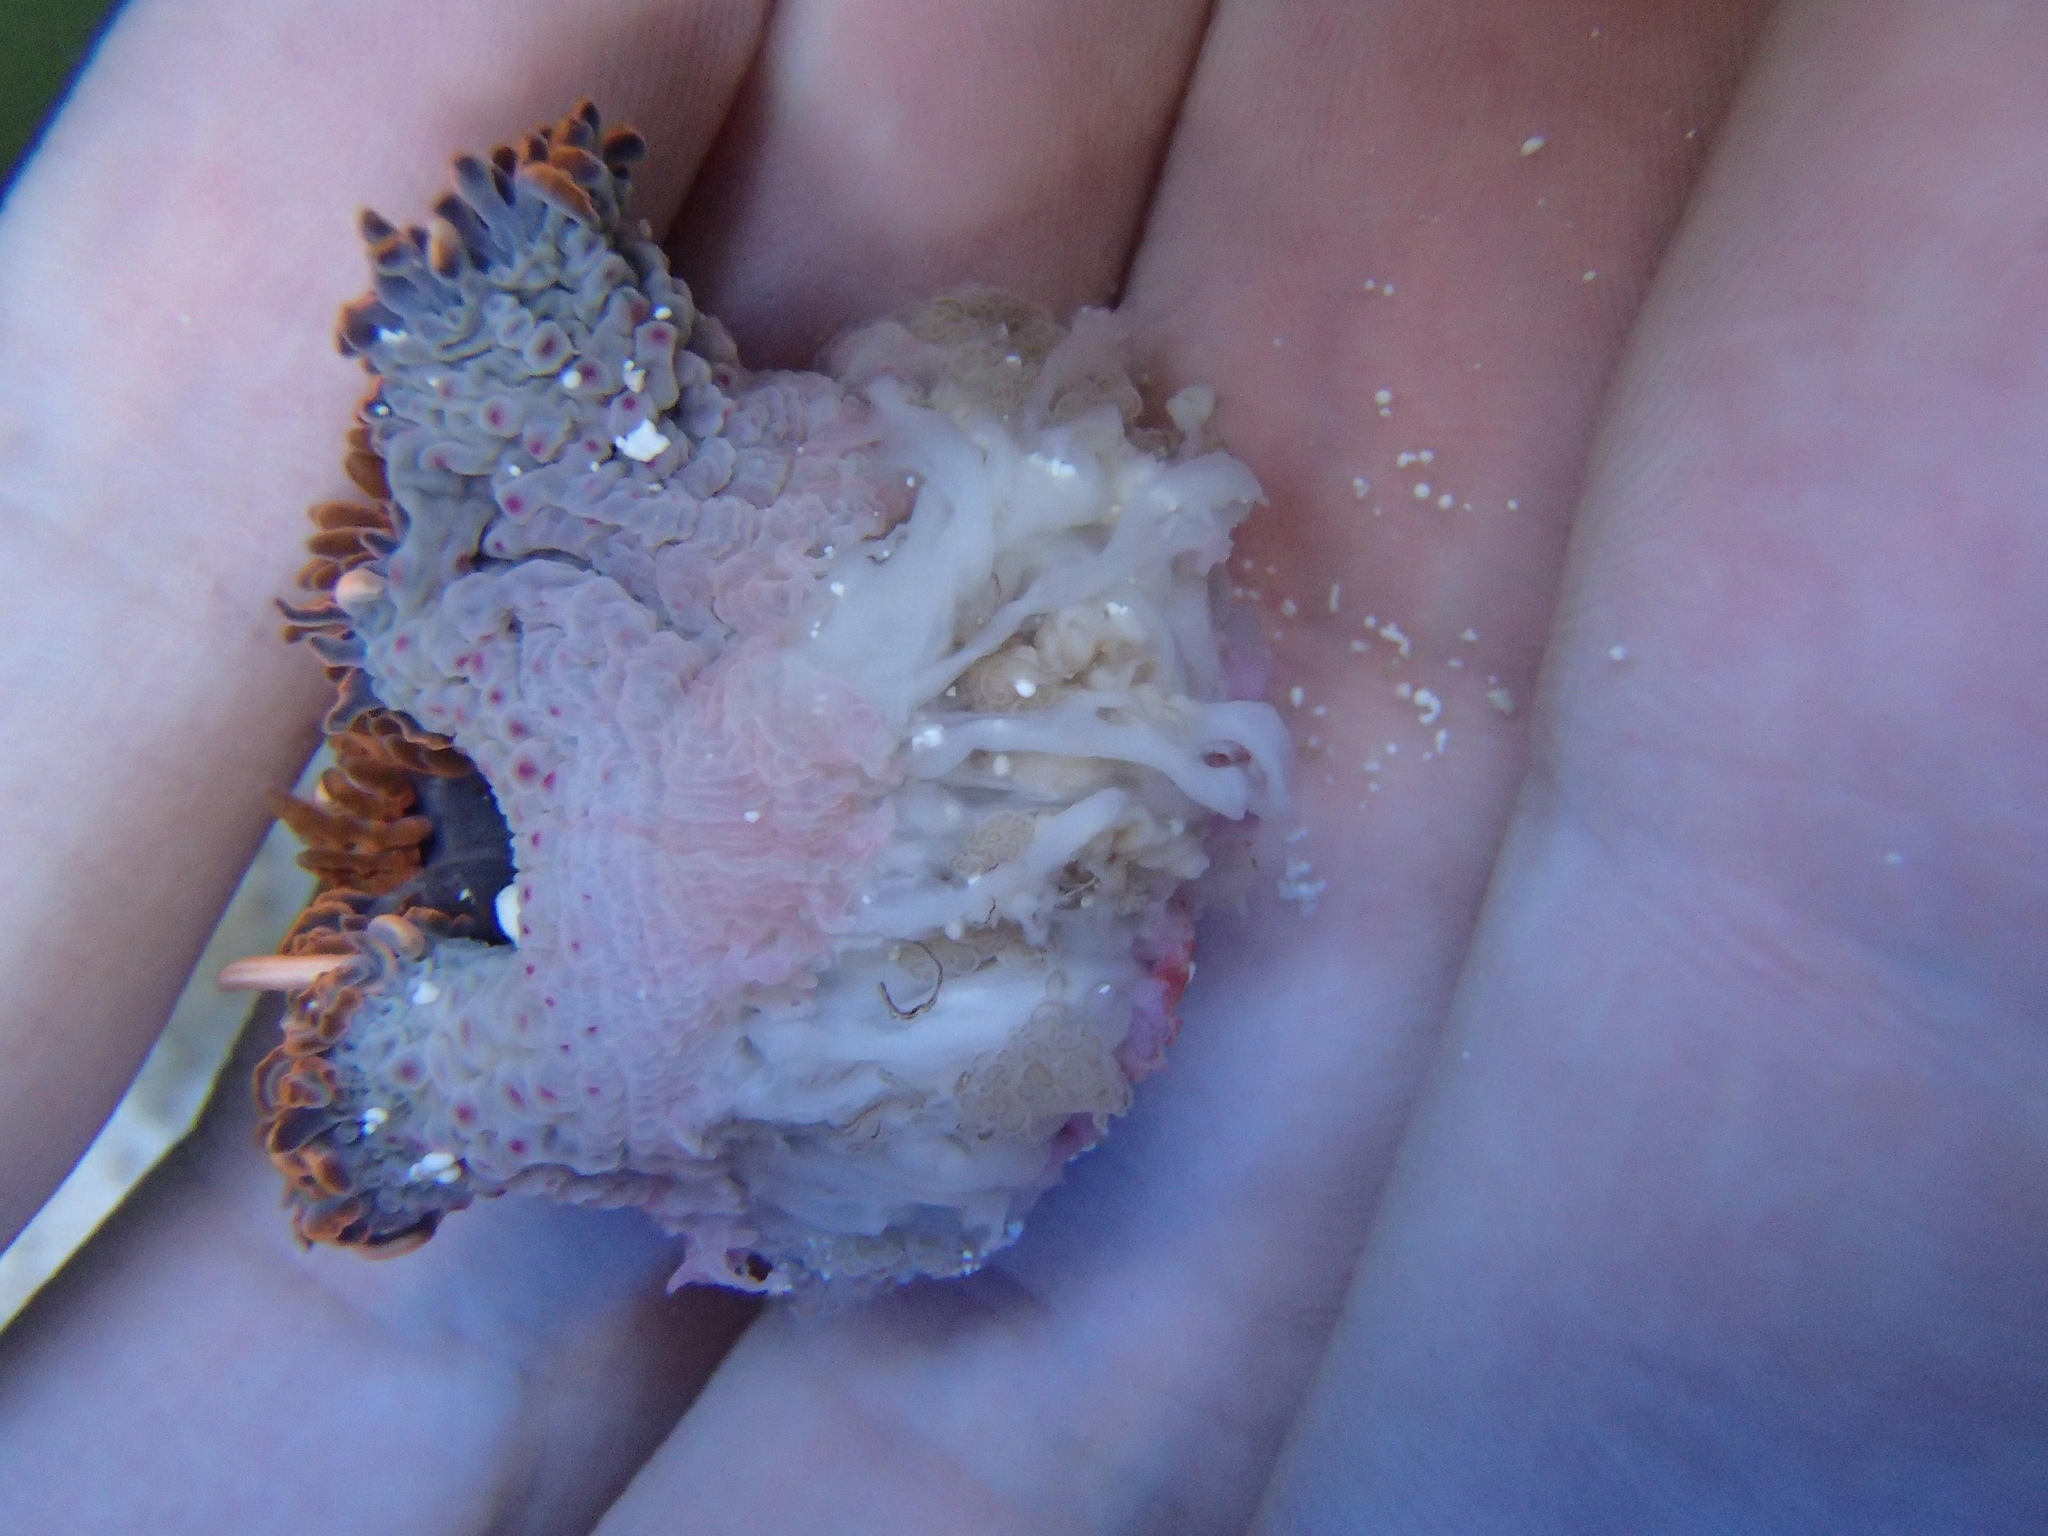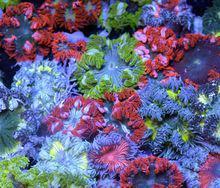The first image is the image on the left, the second image is the image on the right. Evaluate the accuracy of this statement regarding the images: "Atleast one image shows anemone growing on a grid surface, and at least one image features orange-tentacled anemone with pink stalks.". Is it true? Answer yes or no. No. The first image is the image on the left, the second image is the image on the right. Given the left and right images, does the statement "In the image on the right, sea anemones rest in a container with holes in it." hold true? Answer yes or no. No. 